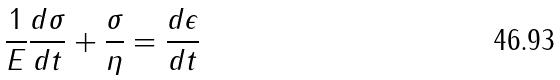Convert formula to latex. <formula><loc_0><loc_0><loc_500><loc_500>\frac { 1 } { E } \frac { d \sigma } { d t } + \frac { \sigma } { \eta } = \frac { d \epsilon } { d t }</formula> 